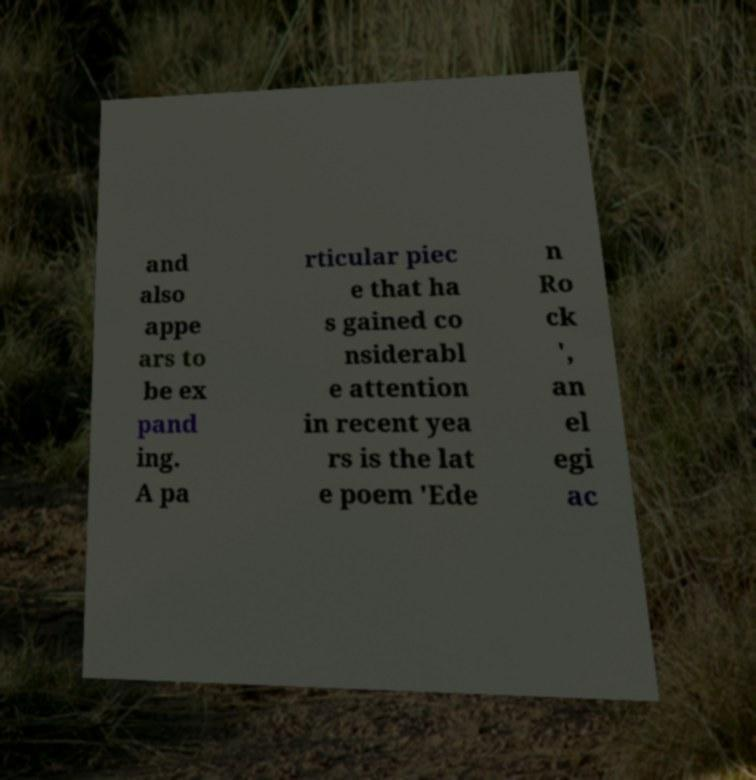Please identify and transcribe the text found in this image. and also appe ars to be ex pand ing. A pa rticular piec e that ha s gained co nsiderabl e attention in recent yea rs is the lat e poem 'Ede n Ro ck ', an el egi ac 